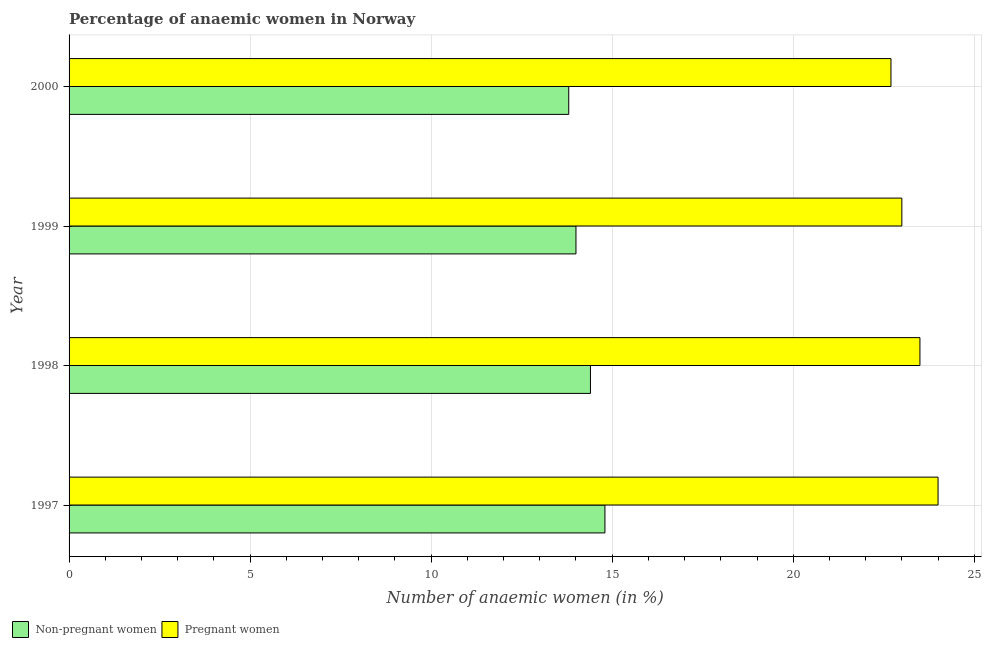How many different coloured bars are there?
Keep it short and to the point. 2. How many groups of bars are there?
Your answer should be very brief. 4. Are the number of bars on each tick of the Y-axis equal?
Keep it short and to the point. Yes. How many bars are there on the 1st tick from the bottom?
Your answer should be very brief. 2. What is the label of the 1st group of bars from the top?
Provide a short and direct response. 2000. Across all years, what is the maximum percentage of pregnant anaemic women?
Your answer should be compact. 24. Across all years, what is the minimum percentage of non-pregnant anaemic women?
Offer a very short reply. 13.8. What is the total percentage of pregnant anaemic women in the graph?
Your answer should be compact. 93.2. What is the average percentage of pregnant anaemic women per year?
Your answer should be compact. 23.3. In the year 2000, what is the difference between the percentage of non-pregnant anaemic women and percentage of pregnant anaemic women?
Give a very brief answer. -8.9. Is the difference between the percentage of non-pregnant anaemic women in 1997 and 1998 greater than the difference between the percentage of pregnant anaemic women in 1997 and 1998?
Your answer should be very brief. No. Is the sum of the percentage of non-pregnant anaemic women in 1999 and 2000 greater than the maximum percentage of pregnant anaemic women across all years?
Offer a terse response. Yes. What does the 2nd bar from the top in 1999 represents?
Provide a short and direct response. Non-pregnant women. What does the 2nd bar from the bottom in 1998 represents?
Offer a very short reply. Pregnant women. How many bars are there?
Your answer should be very brief. 8. What is the difference between two consecutive major ticks on the X-axis?
Offer a terse response. 5. Are the values on the major ticks of X-axis written in scientific E-notation?
Provide a succinct answer. No. Does the graph contain any zero values?
Make the answer very short. No. Does the graph contain grids?
Keep it short and to the point. Yes. How are the legend labels stacked?
Your answer should be compact. Horizontal. What is the title of the graph?
Give a very brief answer. Percentage of anaemic women in Norway. Does "Current US$" appear as one of the legend labels in the graph?
Your response must be concise. No. What is the label or title of the X-axis?
Provide a succinct answer. Number of anaemic women (in %). What is the label or title of the Y-axis?
Your answer should be compact. Year. What is the Number of anaemic women (in %) in Non-pregnant women in 1997?
Your answer should be compact. 14.8. What is the Number of anaemic women (in %) in Non-pregnant women in 1998?
Offer a very short reply. 14.4. What is the Number of anaemic women (in %) of Pregnant women in 1998?
Provide a short and direct response. 23.5. What is the Number of anaemic women (in %) in Non-pregnant women in 1999?
Provide a short and direct response. 14. What is the Number of anaemic women (in %) in Non-pregnant women in 2000?
Keep it short and to the point. 13.8. What is the Number of anaemic women (in %) in Pregnant women in 2000?
Make the answer very short. 22.7. Across all years, what is the maximum Number of anaemic women (in %) of Non-pregnant women?
Your response must be concise. 14.8. Across all years, what is the minimum Number of anaemic women (in %) in Non-pregnant women?
Offer a terse response. 13.8. Across all years, what is the minimum Number of anaemic women (in %) of Pregnant women?
Keep it short and to the point. 22.7. What is the total Number of anaemic women (in %) of Pregnant women in the graph?
Make the answer very short. 93.2. What is the difference between the Number of anaemic women (in %) in Non-pregnant women in 1997 and that in 1998?
Make the answer very short. 0.4. What is the difference between the Number of anaemic women (in %) in Non-pregnant women in 1997 and that in 1999?
Provide a succinct answer. 0.8. What is the difference between the Number of anaemic women (in %) in Pregnant women in 1997 and that in 1999?
Your answer should be compact. 1. What is the difference between the Number of anaemic women (in %) in Pregnant women in 1997 and that in 2000?
Your answer should be compact. 1.3. What is the difference between the Number of anaemic women (in %) in Non-pregnant women in 1998 and that in 1999?
Offer a very short reply. 0.4. What is the difference between the Number of anaemic women (in %) of Pregnant women in 1998 and that in 1999?
Your answer should be compact. 0.5. What is the difference between the Number of anaemic women (in %) in Non-pregnant women in 1998 and that in 2000?
Offer a very short reply. 0.6. What is the difference between the Number of anaemic women (in %) in Non-pregnant women in 1998 and the Number of anaemic women (in %) in Pregnant women in 2000?
Ensure brevity in your answer.  -8.3. What is the difference between the Number of anaemic women (in %) of Non-pregnant women in 1999 and the Number of anaemic women (in %) of Pregnant women in 2000?
Your answer should be very brief. -8.7. What is the average Number of anaemic women (in %) of Non-pregnant women per year?
Offer a terse response. 14.25. What is the average Number of anaemic women (in %) in Pregnant women per year?
Offer a very short reply. 23.3. In the year 1997, what is the difference between the Number of anaemic women (in %) in Non-pregnant women and Number of anaemic women (in %) in Pregnant women?
Provide a succinct answer. -9.2. In the year 1999, what is the difference between the Number of anaemic women (in %) of Non-pregnant women and Number of anaemic women (in %) of Pregnant women?
Offer a terse response. -9. In the year 2000, what is the difference between the Number of anaemic women (in %) in Non-pregnant women and Number of anaemic women (in %) in Pregnant women?
Provide a short and direct response. -8.9. What is the ratio of the Number of anaemic women (in %) of Non-pregnant women in 1997 to that in 1998?
Offer a very short reply. 1.03. What is the ratio of the Number of anaemic women (in %) in Pregnant women in 1997 to that in 1998?
Your response must be concise. 1.02. What is the ratio of the Number of anaemic women (in %) in Non-pregnant women in 1997 to that in 1999?
Ensure brevity in your answer.  1.06. What is the ratio of the Number of anaemic women (in %) of Pregnant women in 1997 to that in 1999?
Provide a succinct answer. 1.04. What is the ratio of the Number of anaemic women (in %) in Non-pregnant women in 1997 to that in 2000?
Your answer should be very brief. 1.07. What is the ratio of the Number of anaemic women (in %) of Pregnant women in 1997 to that in 2000?
Make the answer very short. 1.06. What is the ratio of the Number of anaemic women (in %) of Non-pregnant women in 1998 to that in 1999?
Provide a succinct answer. 1.03. What is the ratio of the Number of anaemic women (in %) of Pregnant women in 1998 to that in 1999?
Provide a succinct answer. 1.02. What is the ratio of the Number of anaemic women (in %) in Non-pregnant women in 1998 to that in 2000?
Keep it short and to the point. 1.04. What is the ratio of the Number of anaemic women (in %) in Pregnant women in 1998 to that in 2000?
Your response must be concise. 1.04. What is the ratio of the Number of anaemic women (in %) of Non-pregnant women in 1999 to that in 2000?
Provide a short and direct response. 1.01. What is the ratio of the Number of anaemic women (in %) in Pregnant women in 1999 to that in 2000?
Your answer should be compact. 1.01. What is the difference between the highest and the second highest Number of anaemic women (in %) of Pregnant women?
Offer a very short reply. 0.5. What is the difference between the highest and the lowest Number of anaemic women (in %) of Pregnant women?
Keep it short and to the point. 1.3. 